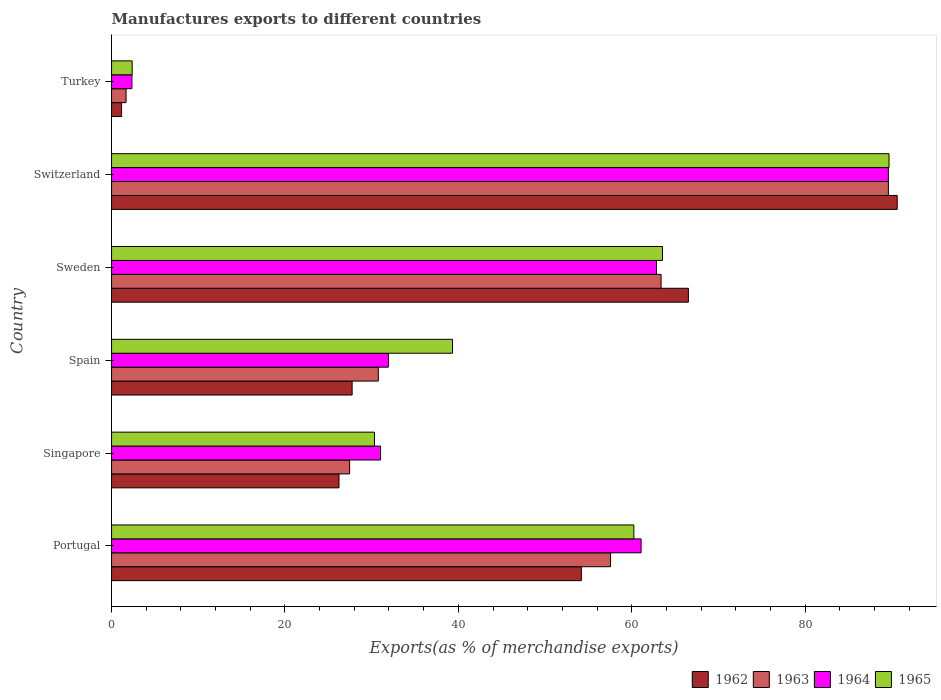Are the number of bars per tick equal to the number of legend labels?
Give a very brief answer. Yes. How many bars are there on the 4th tick from the bottom?
Offer a terse response. 4. What is the label of the 2nd group of bars from the top?
Provide a succinct answer. Switzerland. What is the percentage of exports to different countries in 1964 in Spain?
Offer a very short reply. 31.93. Across all countries, what is the maximum percentage of exports to different countries in 1964?
Keep it short and to the point. 89.61. Across all countries, what is the minimum percentage of exports to different countries in 1963?
Ensure brevity in your answer.  1.67. In which country was the percentage of exports to different countries in 1962 maximum?
Your response must be concise. Switzerland. In which country was the percentage of exports to different countries in 1965 minimum?
Your response must be concise. Turkey. What is the total percentage of exports to different countries in 1964 in the graph?
Your answer should be compact. 278.86. What is the difference between the percentage of exports to different countries in 1964 in Singapore and that in Sweden?
Offer a very short reply. -31.83. What is the difference between the percentage of exports to different countries in 1962 in Sweden and the percentage of exports to different countries in 1963 in Spain?
Your answer should be compact. 35.77. What is the average percentage of exports to different countries in 1962 per country?
Provide a short and direct response. 44.42. What is the difference between the percentage of exports to different countries in 1964 and percentage of exports to different countries in 1962 in Sweden?
Your answer should be compact. -3.68. In how many countries, is the percentage of exports to different countries in 1964 greater than 76 %?
Provide a short and direct response. 1. What is the ratio of the percentage of exports to different countries in 1965 in Sweden to that in Switzerland?
Your answer should be very brief. 0.71. Is the difference between the percentage of exports to different countries in 1964 in Portugal and Sweden greater than the difference between the percentage of exports to different countries in 1962 in Portugal and Sweden?
Make the answer very short. Yes. What is the difference between the highest and the second highest percentage of exports to different countries in 1964?
Your response must be concise. 26.75. What is the difference between the highest and the lowest percentage of exports to different countries in 1963?
Make the answer very short. 87.94. In how many countries, is the percentage of exports to different countries in 1963 greater than the average percentage of exports to different countries in 1963 taken over all countries?
Offer a terse response. 3. What does the 2nd bar from the top in Spain represents?
Your answer should be compact. 1964. What does the 2nd bar from the bottom in Turkey represents?
Provide a succinct answer. 1963. Is it the case that in every country, the sum of the percentage of exports to different countries in 1964 and percentage of exports to different countries in 1965 is greater than the percentage of exports to different countries in 1962?
Make the answer very short. Yes. How many bars are there?
Offer a terse response. 24. Does the graph contain any zero values?
Provide a short and direct response. No. Where does the legend appear in the graph?
Provide a short and direct response. Bottom right. How many legend labels are there?
Your answer should be compact. 4. What is the title of the graph?
Give a very brief answer. Manufactures exports to different countries. Does "1983" appear as one of the legend labels in the graph?
Offer a terse response. No. What is the label or title of the X-axis?
Offer a very short reply. Exports(as % of merchandise exports). What is the label or title of the Y-axis?
Keep it short and to the point. Country. What is the Exports(as % of merchandise exports) in 1962 in Portugal?
Ensure brevity in your answer.  54.19. What is the Exports(as % of merchandise exports) of 1963 in Portugal?
Provide a short and direct response. 57.56. What is the Exports(as % of merchandise exports) of 1964 in Portugal?
Offer a terse response. 61.08. What is the Exports(as % of merchandise exports) in 1965 in Portugal?
Make the answer very short. 60.25. What is the Exports(as % of merchandise exports) of 1962 in Singapore?
Offer a very short reply. 26.24. What is the Exports(as % of merchandise exports) in 1963 in Singapore?
Ensure brevity in your answer.  27.46. What is the Exports(as % of merchandise exports) in 1964 in Singapore?
Give a very brief answer. 31.03. What is the Exports(as % of merchandise exports) of 1965 in Singapore?
Offer a very short reply. 30.33. What is the Exports(as % of merchandise exports) of 1962 in Spain?
Give a very brief answer. 27.75. What is the Exports(as % of merchandise exports) in 1963 in Spain?
Your response must be concise. 30.77. What is the Exports(as % of merchandise exports) in 1964 in Spain?
Make the answer very short. 31.93. What is the Exports(as % of merchandise exports) of 1965 in Spain?
Offer a very short reply. 39.33. What is the Exports(as % of merchandise exports) of 1962 in Sweden?
Make the answer very short. 66.54. What is the Exports(as % of merchandise exports) of 1963 in Sweden?
Keep it short and to the point. 63.39. What is the Exports(as % of merchandise exports) of 1964 in Sweden?
Keep it short and to the point. 62.86. What is the Exports(as % of merchandise exports) in 1965 in Sweden?
Your answer should be very brief. 63.55. What is the Exports(as % of merchandise exports) of 1962 in Switzerland?
Your answer should be very brief. 90.63. What is the Exports(as % of merchandise exports) of 1963 in Switzerland?
Your response must be concise. 89.61. What is the Exports(as % of merchandise exports) in 1964 in Switzerland?
Offer a very short reply. 89.61. What is the Exports(as % of merchandise exports) in 1965 in Switzerland?
Make the answer very short. 89.68. What is the Exports(as % of merchandise exports) in 1962 in Turkey?
Your response must be concise. 1.16. What is the Exports(as % of merchandise exports) in 1963 in Turkey?
Ensure brevity in your answer.  1.67. What is the Exports(as % of merchandise exports) of 1964 in Turkey?
Your response must be concise. 2.35. What is the Exports(as % of merchandise exports) in 1965 in Turkey?
Your answer should be compact. 2.38. Across all countries, what is the maximum Exports(as % of merchandise exports) in 1962?
Offer a terse response. 90.63. Across all countries, what is the maximum Exports(as % of merchandise exports) in 1963?
Make the answer very short. 89.61. Across all countries, what is the maximum Exports(as % of merchandise exports) in 1964?
Ensure brevity in your answer.  89.61. Across all countries, what is the maximum Exports(as % of merchandise exports) of 1965?
Ensure brevity in your answer.  89.68. Across all countries, what is the minimum Exports(as % of merchandise exports) in 1962?
Provide a succinct answer. 1.16. Across all countries, what is the minimum Exports(as % of merchandise exports) in 1963?
Offer a terse response. 1.67. Across all countries, what is the minimum Exports(as % of merchandise exports) in 1964?
Provide a short and direct response. 2.35. Across all countries, what is the minimum Exports(as % of merchandise exports) of 1965?
Give a very brief answer. 2.38. What is the total Exports(as % of merchandise exports) of 1962 in the graph?
Provide a succinct answer. 266.5. What is the total Exports(as % of merchandise exports) in 1963 in the graph?
Offer a terse response. 270.46. What is the total Exports(as % of merchandise exports) in 1964 in the graph?
Keep it short and to the point. 278.86. What is the total Exports(as % of merchandise exports) in 1965 in the graph?
Offer a terse response. 285.53. What is the difference between the Exports(as % of merchandise exports) of 1962 in Portugal and that in Singapore?
Your answer should be very brief. 27.96. What is the difference between the Exports(as % of merchandise exports) in 1963 in Portugal and that in Singapore?
Your response must be concise. 30.1. What is the difference between the Exports(as % of merchandise exports) in 1964 in Portugal and that in Singapore?
Your answer should be compact. 30.05. What is the difference between the Exports(as % of merchandise exports) in 1965 in Portugal and that in Singapore?
Make the answer very short. 29.92. What is the difference between the Exports(as % of merchandise exports) in 1962 in Portugal and that in Spain?
Provide a short and direct response. 26.44. What is the difference between the Exports(as % of merchandise exports) in 1963 in Portugal and that in Spain?
Provide a short and direct response. 26.79. What is the difference between the Exports(as % of merchandise exports) in 1964 in Portugal and that in Spain?
Keep it short and to the point. 29.15. What is the difference between the Exports(as % of merchandise exports) in 1965 in Portugal and that in Spain?
Offer a terse response. 20.92. What is the difference between the Exports(as % of merchandise exports) in 1962 in Portugal and that in Sweden?
Keep it short and to the point. -12.35. What is the difference between the Exports(as % of merchandise exports) of 1963 in Portugal and that in Sweden?
Give a very brief answer. -5.83. What is the difference between the Exports(as % of merchandise exports) in 1964 in Portugal and that in Sweden?
Keep it short and to the point. -1.77. What is the difference between the Exports(as % of merchandise exports) in 1965 in Portugal and that in Sweden?
Make the answer very short. -3.3. What is the difference between the Exports(as % of merchandise exports) in 1962 in Portugal and that in Switzerland?
Provide a succinct answer. -36.44. What is the difference between the Exports(as % of merchandise exports) in 1963 in Portugal and that in Switzerland?
Ensure brevity in your answer.  -32.05. What is the difference between the Exports(as % of merchandise exports) in 1964 in Portugal and that in Switzerland?
Your answer should be very brief. -28.53. What is the difference between the Exports(as % of merchandise exports) in 1965 in Portugal and that in Switzerland?
Provide a short and direct response. -29.43. What is the difference between the Exports(as % of merchandise exports) of 1962 in Portugal and that in Turkey?
Keep it short and to the point. 53.04. What is the difference between the Exports(as % of merchandise exports) of 1963 in Portugal and that in Turkey?
Give a very brief answer. 55.89. What is the difference between the Exports(as % of merchandise exports) in 1964 in Portugal and that in Turkey?
Keep it short and to the point. 58.73. What is the difference between the Exports(as % of merchandise exports) of 1965 in Portugal and that in Turkey?
Keep it short and to the point. 57.87. What is the difference between the Exports(as % of merchandise exports) of 1962 in Singapore and that in Spain?
Your response must be concise. -1.51. What is the difference between the Exports(as % of merchandise exports) in 1963 in Singapore and that in Spain?
Make the answer very short. -3.31. What is the difference between the Exports(as % of merchandise exports) in 1964 in Singapore and that in Spain?
Make the answer very short. -0.9. What is the difference between the Exports(as % of merchandise exports) in 1965 in Singapore and that in Spain?
Make the answer very short. -9. What is the difference between the Exports(as % of merchandise exports) in 1962 in Singapore and that in Sweden?
Give a very brief answer. -40.3. What is the difference between the Exports(as % of merchandise exports) of 1963 in Singapore and that in Sweden?
Your response must be concise. -35.93. What is the difference between the Exports(as % of merchandise exports) of 1964 in Singapore and that in Sweden?
Ensure brevity in your answer.  -31.83. What is the difference between the Exports(as % of merchandise exports) in 1965 in Singapore and that in Sweden?
Keep it short and to the point. -33.22. What is the difference between the Exports(as % of merchandise exports) in 1962 in Singapore and that in Switzerland?
Ensure brevity in your answer.  -64.39. What is the difference between the Exports(as % of merchandise exports) in 1963 in Singapore and that in Switzerland?
Ensure brevity in your answer.  -62.15. What is the difference between the Exports(as % of merchandise exports) in 1964 in Singapore and that in Switzerland?
Provide a succinct answer. -58.58. What is the difference between the Exports(as % of merchandise exports) of 1965 in Singapore and that in Switzerland?
Offer a terse response. -59.35. What is the difference between the Exports(as % of merchandise exports) of 1962 in Singapore and that in Turkey?
Ensure brevity in your answer.  25.08. What is the difference between the Exports(as % of merchandise exports) of 1963 in Singapore and that in Turkey?
Your response must be concise. 25.79. What is the difference between the Exports(as % of merchandise exports) of 1964 in Singapore and that in Turkey?
Offer a very short reply. 28.68. What is the difference between the Exports(as % of merchandise exports) in 1965 in Singapore and that in Turkey?
Offer a terse response. 27.95. What is the difference between the Exports(as % of merchandise exports) of 1962 in Spain and that in Sweden?
Your response must be concise. -38.79. What is the difference between the Exports(as % of merchandise exports) of 1963 in Spain and that in Sweden?
Your answer should be very brief. -32.62. What is the difference between the Exports(as % of merchandise exports) in 1964 in Spain and that in Sweden?
Give a very brief answer. -30.92. What is the difference between the Exports(as % of merchandise exports) in 1965 in Spain and that in Sweden?
Your response must be concise. -24.22. What is the difference between the Exports(as % of merchandise exports) of 1962 in Spain and that in Switzerland?
Provide a short and direct response. -62.88. What is the difference between the Exports(as % of merchandise exports) of 1963 in Spain and that in Switzerland?
Make the answer very short. -58.84. What is the difference between the Exports(as % of merchandise exports) in 1964 in Spain and that in Switzerland?
Give a very brief answer. -57.68. What is the difference between the Exports(as % of merchandise exports) in 1965 in Spain and that in Switzerland?
Your answer should be very brief. -50.35. What is the difference between the Exports(as % of merchandise exports) of 1962 in Spain and that in Turkey?
Give a very brief answer. 26.59. What is the difference between the Exports(as % of merchandise exports) of 1963 in Spain and that in Turkey?
Your answer should be compact. 29.1. What is the difference between the Exports(as % of merchandise exports) of 1964 in Spain and that in Turkey?
Provide a short and direct response. 29.58. What is the difference between the Exports(as % of merchandise exports) in 1965 in Spain and that in Turkey?
Offer a terse response. 36.96. What is the difference between the Exports(as % of merchandise exports) in 1962 in Sweden and that in Switzerland?
Ensure brevity in your answer.  -24.09. What is the difference between the Exports(as % of merchandise exports) in 1963 in Sweden and that in Switzerland?
Your answer should be very brief. -26.22. What is the difference between the Exports(as % of merchandise exports) of 1964 in Sweden and that in Switzerland?
Provide a short and direct response. -26.75. What is the difference between the Exports(as % of merchandise exports) in 1965 in Sweden and that in Switzerland?
Give a very brief answer. -26.13. What is the difference between the Exports(as % of merchandise exports) in 1962 in Sweden and that in Turkey?
Keep it short and to the point. 65.38. What is the difference between the Exports(as % of merchandise exports) in 1963 in Sweden and that in Turkey?
Offer a terse response. 61.72. What is the difference between the Exports(as % of merchandise exports) in 1964 in Sweden and that in Turkey?
Provide a short and direct response. 60.51. What is the difference between the Exports(as % of merchandise exports) in 1965 in Sweden and that in Turkey?
Your answer should be compact. 61.17. What is the difference between the Exports(as % of merchandise exports) of 1962 in Switzerland and that in Turkey?
Provide a succinct answer. 89.47. What is the difference between the Exports(as % of merchandise exports) in 1963 in Switzerland and that in Turkey?
Your answer should be very brief. 87.94. What is the difference between the Exports(as % of merchandise exports) in 1964 in Switzerland and that in Turkey?
Offer a very short reply. 87.26. What is the difference between the Exports(as % of merchandise exports) in 1965 in Switzerland and that in Turkey?
Make the answer very short. 87.31. What is the difference between the Exports(as % of merchandise exports) of 1962 in Portugal and the Exports(as % of merchandise exports) of 1963 in Singapore?
Provide a short and direct response. 26.73. What is the difference between the Exports(as % of merchandise exports) in 1962 in Portugal and the Exports(as % of merchandise exports) in 1964 in Singapore?
Your answer should be compact. 23.16. What is the difference between the Exports(as % of merchandise exports) in 1962 in Portugal and the Exports(as % of merchandise exports) in 1965 in Singapore?
Give a very brief answer. 23.86. What is the difference between the Exports(as % of merchandise exports) in 1963 in Portugal and the Exports(as % of merchandise exports) in 1964 in Singapore?
Provide a short and direct response. 26.53. What is the difference between the Exports(as % of merchandise exports) of 1963 in Portugal and the Exports(as % of merchandise exports) of 1965 in Singapore?
Keep it short and to the point. 27.23. What is the difference between the Exports(as % of merchandise exports) in 1964 in Portugal and the Exports(as % of merchandise exports) in 1965 in Singapore?
Give a very brief answer. 30.75. What is the difference between the Exports(as % of merchandise exports) of 1962 in Portugal and the Exports(as % of merchandise exports) of 1963 in Spain?
Your answer should be compact. 23.42. What is the difference between the Exports(as % of merchandise exports) in 1962 in Portugal and the Exports(as % of merchandise exports) in 1964 in Spain?
Your response must be concise. 22.26. What is the difference between the Exports(as % of merchandise exports) of 1962 in Portugal and the Exports(as % of merchandise exports) of 1965 in Spain?
Make the answer very short. 14.86. What is the difference between the Exports(as % of merchandise exports) of 1963 in Portugal and the Exports(as % of merchandise exports) of 1964 in Spain?
Offer a terse response. 25.63. What is the difference between the Exports(as % of merchandise exports) of 1963 in Portugal and the Exports(as % of merchandise exports) of 1965 in Spain?
Offer a very short reply. 18.23. What is the difference between the Exports(as % of merchandise exports) of 1964 in Portugal and the Exports(as % of merchandise exports) of 1965 in Spain?
Keep it short and to the point. 21.75. What is the difference between the Exports(as % of merchandise exports) of 1962 in Portugal and the Exports(as % of merchandise exports) of 1963 in Sweden?
Your answer should be compact. -9.2. What is the difference between the Exports(as % of merchandise exports) of 1962 in Portugal and the Exports(as % of merchandise exports) of 1964 in Sweden?
Ensure brevity in your answer.  -8.66. What is the difference between the Exports(as % of merchandise exports) in 1962 in Portugal and the Exports(as % of merchandise exports) in 1965 in Sweden?
Give a very brief answer. -9.36. What is the difference between the Exports(as % of merchandise exports) of 1963 in Portugal and the Exports(as % of merchandise exports) of 1964 in Sweden?
Provide a succinct answer. -5.3. What is the difference between the Exports(as % of merchandise exports) of 1963 in Portugal and the Exports(as % of merchandise exports) of 1965 in Sweden?
Your answer should be compact. -5.99. What is the difference between the Exports(as % of merchandise exports) of 1964 in Portugal and the Exports(as % of merchandise exports) of 1965 in Sweden?
Provide a succinct answer. -2.47. What is the difference between the Exports(as % of merchandise exports) in 1962 in Portugal and the Exports(as % of merchandise exports) in 1963 in Switzerland?
Offer a terse response. -35.42. What is the difference between the Exports(as % of merchandise exports) in 1962 in Portugal and the Exports(as % of merchandise exports) in 1964 in Switzerland?
Give a very brief answer. -35.42. What is the difference between the Exports(as % of merchandise exports) of 1962 in Portugal and the Exports(as % of merchandise exports) of 1965 in Switzerland?
Offer a very short reply. -35.49. What is the difference between the Exports(as % of merchandise exports) of 1963 in Portugal and the Exports(as % of merchandise exports) of 1964 in Switzerland?
Provide a succinct answer. -32.05. What is the difference between the Exports(as % of merchandise exports) in 1963 in Portugal and the Exports(as % of merchandise exports) in 1965 in Switzerland?
Your answer should be very brief. -32.12. What is the difference between the Exports(as % of merchandise exports) of 1964 in Portugal and the Exports(as % of merchandise exports) of 1965 in Switzerland?
Your response must be concise. -28.6. What is the difference between the Exports(as % of merchandise exports) of 1962 in Portugal and the Exports(as % of merchandise exports) of 1963 in Turkey?
Provide a short and direct response. 52.52. What is the difference between the Exports(as % of merchandise exports) in 1962 in Portugal and the Exports(as % of merchandise exports) in 1964 in Turkey?
Make the answer very short. 51.84. What is the difference between the Exports(as % of merchandise exports) of 1962 in Portugal and the Exports(as % of merchandise exports) of 1965 in Turkey?
Make the answer very short. 51.81. What is the difference between the Exports(as % of merchandise exports) of 1963 in Portugal and the Exports(as % of merchandise exports) of 1964 in Turkey?
Give a very brief answer. 55.21. What is the difference between the Exports(as % of merchandise exports) in 1963 in Portugal and the Exports(as % of merchandise exports) in 1965 in Turkey?
Offer a terse response. 55.18. What is the difference between the Exports(as % of merchandise exports) in 1964 in Portugal and the Exports(as % of merchandise exports) in 1965 in Turkey?
Make the answer very short. 58.7. What is the difference between the Exports(as % of merchandise exports) of 1962 in Singapore and the Exports(as % of merchandise exports) of 1963 in Spain?
Your response must be concise. -4.53. What is the difference between the Exports(as % of merchandise exports) of 1962 in Singapore and the Exports(as % of merchandise exports) of 1964 in Spain?
Your answer should be very brief. -5.7. What is the difference between the Exports(as % of merchandise exports) in 1962 in Singapore and the Exports(as % of merchandise exports) in 1965 in Spain?
Your response must be concise. -13.1. What is the difference between the Exports(as % of merchandise exports) of 1963 in Singapore and the Exports(as % of merchandise exports) of 1964 in Spain?
Your answer should be compact. -4.47. What is the difference between the Exports(as % of merchandise exports) of 1963 in Singapore and the Exports(as % of merchandise exports) of 1965 in Spain?
Make the answer very short. -11.87. What is the difference between the Exports(as % of merchandise exports) in 1964 in Singapore and the Exports(as % of merchandise exports) in 1965 in Spain?
Offer a terse response. -8.3. What is the difference between the Exports(as % of merchandise exports) in 1962 in Singapore and the Exports(as % of merchandise exports) in 1963 in Sweden?
Ensure brevity in your answer.  -37.15. What is the difference between the Exports(as % of merchandise exports) of 1962 in Singapore and the Exports(as % of merchandise exports) of 1964 in Sweden?
Your answer should be compact. -36.62. What is the difference between the Exports(as % of merchandise exports) of 1962 in Singapore and the Exports(as % of merchandise exports) of 1965 in Sweden?
Give a very brief answer. -37.31. What is the difference between the Exports(as % of merchandise exports) in 1963 in Singapore and the Exports(as % of merchandise exports) in 1964 in Sweden?
Your answer should be very brief. -35.4. What is the difference between the Exports(as % of merchandise exports) of 1963 in Singapore and the Exports(as % of merchandise exports) of 1965 in Sweden?
Provide a succinct answer. -36.09. What is the difference between the Exports(as % of merchandise exports) in 1964 in Singapore and the Exports(as % of merchandise exports) in 1965 in Sweden?
Give a very brief answer. -32.52. What is the difference between the Exports(as % of merchandise exports) in 1962 in Singapore and the Exports(as % of merchandise exports) in 1963 in Switzerland?
Your response must be concise. -63.37. What is the difference between the Exports(as % of merchandise exports) in 1962 in Singapore and the Exports(as % of merchandise exports) in 1964 in Switzerland?
Make the answer very short. -63.37. What is the difference between the Exports(as % of merchandise exports) of 1962 in Singapore and the Exports(as % of merchandise exports) of 1965 in Switzerland?
Give a very brief answer. -63.45. What is the difference between the Exports(as % of merchandise exports) in 1963 in Singapore and the Exports(as % of merchandise exports) in 1964 in Switzerland?
Offer a very short reply. -62.15. What is the difference between the Exports(as % of merchandise exports) of 1963 in Singapore and the Exports(as % of merchandise exports) of 1965 in Switzerland?
Offer a very short reply. -62.22. What is the difference between the Exports(as % of merchandise exports) of 1964 in Singapore and the Exports(as % of merchandise exports) of 1965 in Switzerland?
Provide a succinct answer. -58.65. What is the difference between the Exports(as % of merchandise exports) of 1962 in Singapore and the Exports(as % of merchandise exports) of 1963 in Turkey?
Your answer should be compact. 24.56. What is the difference between the Exports(as % of merchandise exports) in 1962 in Singapore and the Exports(as % of merchandise exports) in 1964 in Turkey?
Give a very brief answer. 23.89. What is the difference between the Exports(as % of merchandise exports) of 1962 in Singapore and the Exports(as % of merchandise exports) of 1965 in Turkey?
Your answer should be very brief. 23.86. What is the difference between the Exports(as % of merchandise exports) of 1963 in Singapore and the Exports(as % of merchandise exports) of 1964 in Turkey?
Make the answer very short. 25.11. What is the difference between the Exports(as % of merchandise exports) of 1963 in Singapore and the Exports(as % of merchandise exports) of 1965 in Turkey?
Your response must be concise. 25.08. What is the difference between the Exports(as % of merchandise exports) of 1964 in Singapore and the Exports(as % of merchandise exports) of 1965 in Turkey?
Provide a short and direct response. 28.65. What is the difference between the Exports(as % of merchandise exports) in 1962 in Spain and the Exports(as % of merchandise exports) in 1963 in Sweden?
Offer a terse response. -35.64. What is the difference between the Exports(as % of merchandise exports) in 1962 in Spain and the Exports(as % of merchandise exports) in 1964 in Sweden?
Your response must be concise. -35.11. What is the difference between the Exports(as % of merchandise exports) of 1962 in Spain and the Exports(as % of merchandise exports) of 1965 in Sweden?
Offer a very short reply. -35.8. What is the difference between the Exports(as % of merchandise exports) of 1963 in Spain and the Exports(as % of merchandise exports) of 1964 in Sweden?
Your answer should be very brief. -32.09. What is the difference between the Exports(as % of merchandise exports) of 1963 in Spain and the Exports(as % of merchandise exports) of 1965 in Sweden?
Offer a terse response. -32.78. What is the difference between the Exports(as % of merchandise exports) in 1964 in Spain and the Exports(as % of merchandise exports) in 1965 in Sweden?
Keep it short and to the point. -31.62. What is the difference between the Exports(as % of merchandise exports) of 1962 in Spain and the Exports(as % of merchandise exports) of 1963 in Switzerland?
Make the answer very short. -61.86. What is the difference between the Exports(as % of merchandise exports) of 1962 in Spain and the Exports(as % of merchandise exports) of 1964 in Switzerland?
Your answer should be compact. -61.86. What is the difference between the Exports(as % of merchandise exports) in 1962 in Spain and the Exports(as % of merchandise exports) in 1965 in Switzerland?
Give a very brief answer. -61.93. What is the difference between the Exports(as % of merchandise exports) in 1963 in Spain and the Exports(as % of merchandise exports) in 1964 in Switzerland?
Offer a very short reply. -58.84. What is the difference between the Exports(as % of merchandise exports) of 1963 in Spain and the Exports(as % of merchandise exports) of 1965 in Switzerland?
Give a very brief answer. -58.91. What is the difference between the Exports(as % of merchandise exports) of 1964 in Spain and the Exports(as % of merchandise exports) of 1965 in Switzerland?
Provide a short and direct response. -57.75. What is the difference between the Exports(as % of merchandise exports) in 1962 in Spain and the Exports(as % of merchandise exports) in 1963 in Turkey?
Offer a terse response. 26.08. What is the difference between the Exports(as % of merchandise exports) in 1962 in Spain and the Exports(as % of merchandise exports) in 1964 in Turkey?
Offer a terse response. 25.4. What is the difference between the Exports(as % of merchandise exports) in 1962 in Spain and the Exports(as % of merchandise exports) in 1965 in Turkey?
Your answer should be compact. 25.37. What is the difference between the Exports(as % of merchandise exports) of 1963 in Spain and the Exports(as % of merchandise exports) of 1964 in Turkey?
Keep it short and to the point. 28.42. What is the difference between the Exports(as % of merchandise exports) in 1963 in Spain and the Exports(as % of merchandise exports) in 1965 in Turkey?
Your answer should be compact. 28.39. What is the difference between the Exports(as % of merchandise exports) of 1964 in Spain and the Exports(as % of merchandise exports) of 1965 in Turkey?
Offer a terse response. 29.56. What is the difference between the Exports(as % of merchandise exports) in 1962 in Sweden and the Exports(as % of merchandise exports) in 1963 in Switzerland?
Give a very brief answer. -23.07. What is the difference between the Exports(as % of merchandise exports) in 1962 in Sweden and the Exports(as % of merchandise exports) in 1964 in Switzerland?
Keep it short and to the point. -23.07. What is the difference between the Exports(as % of merchandise exports) of 1962 in Sweden and the Exports(as % of merchandise exports) of 1965 in Switzerland?
Ensure brevity in your answer.  -23.15. What is the difference between the Exports(as % of merchandise exports) in 1963 in Sweden and the Exports(as % of merchandise exports) in 1964 in Switzerland?
Ensure brevity in your answer.  -26.22. What is the difference between the Exports(as % of merchandise exports) in 1963 in Sweden and the Exports(as % of merchandise exports) in 1965 in Switzerland?
Give a very brief answer. -26.3. What is the difference between the Exports(as % of merchandise exports) in 1964 in Sweden and the Exports(as % of merchandise exports) in 1965 in Switzerland?
Ensure brevity in your answer.  -26.83. What is the difference between the Exports(as % of merchandise exports) of 1962 in Sweden and the Exports(as % of merchandise exports) of 1963 in Turkey?
Your response must be concise. 64.86. What is the difference between the Exports(as % of merchandise exports) of 1962 in Sweden and the Exports(as % of merchandise exports) of 1964 in Turkey?
Your answer should be compact. 64.19. What is the difference between the Exports(as % of merchandise exports) in 1962 in Sweden and the Exports(as % of merchandise exports) in 1965 in Turkey?
Offer a very short reply. 64.16. What is the difference between the Exports(as % of merchandise exports) in 1963 in Sweden and the Exports(as % of merchandise exports) in 1964 in Turkey?
Make the answer very short. 61.04. What is the difference between the Exports(as % of merchandise exports) of 1963 in Sweden and the Exports(as % of merchandise exports) of 1965 in Turkey?
Your response must be concise. 61.01. What is the difference between the Exports(as % of merchandise exports) in 1964 in Sweden and the Exports(as % of merchandise exports) in 1965 in Turkey?
Your response must be concise. 60.48. What is the difference between the Exports(as % of merchandise exports) in 1962 in Switzerland and the Exports(as % of merchandise exports) in 1963 in Turkey?
Ensure brevity in your answer.  88.95. What is the difference between the Exports(as % of merchandise exports) in 1962 in Switzerland and the Exports(as % of merchandise exports) in 1964 in Turkey?
Provide a short and direct response. 88.28. What is the difference between the Exports(as % of merchandise exports) of 1962 in Switzerland and the Exports(as % of merchandise exports) of 1965 in Turkey?
Your response must be concise. 88.25. What is the difference between the Exports(as % of merchandise exports) in 1963 in Switzerland and the Exports(as % of merchandise exports) in 1964 in Turkey?
Offer a very short reply. 87.26. What is the difference between the Exports(as % of merchandise exports) in 1963 in Switzerland and the Exports(as % of merchandise exports) in 1965 in Turkey?
Provide a short and direct response. 87.23. What is the difference between the Exports(as % of merchandise exports) of 1964 in Switzerland and the Exports(as % of merchandise exports) of 1965 in Turkey?
Offer a terse response. 87.23. What is the average Exports(as % of merchandise exports) in 1962 per country?
Provide a short and direct response. 44.42. What is the average Exports(as % of merchandise exports) of 1963 per country?
Give a very brief answer. 45.08. What is the average Exports(as % of merchandise exports) in 1964 per country?
Your answer should be very brief. 46.48. What is the average Exports(as % of merchandise exports) of 1965 per country?
Offer a terse response. 47.59. What is the difference between the Exports(as % of merchandise exports) of 1962 and Exports(as % of merchandise exports) of 1963 in Portugal?
Make the answer very short. -3.37. What is the difference between the Exports(as % of merchandise exports) of 1962 and Exports(as % of merchandise exports) of 1964 in Portugal?
Your answer should be very brief. -6.89. What is the difference between the Exports(as % of merchandise exports) of 1962 and Exports(as % of merchandise exports) of 1965 in Portugal?
Your answer should be very brief. -6.06. What is the difference between the Exports(as % of merchandise exports) of 1963 and Exports(as % of merchandise exports) of 1964 in Portugal?
Give a very brief answer. -3.52. What is the difference between the Exports(as % of merchandise exports) of 1963 and Exports(as % of merchandise exports) of 1965 in Portugal?
Offer a terse response. -2.69. What is the difference between the Exports(as % of merchandise exports) of 1964 and Exports(as % of merchandise exports) of 1965 in Portugal?
Ensure brevity in your answer.  0.83. What is the difference between the Exports(as % of merchandise exports) of 1962 and Exports(as % of merchandise exports) of 1963 in Singapore?
Give a very brief answer. -1.22. What is the difference between the Exports(as % of merchandise exports) in 1962 and Exports(as % of merchandise exports) in 1964 in Singapore?
Provide a short and direct response. -4.79. What is the difference between the Exports(as % of merchandise exports) in 1962 and Exports(as % of merchandise exports) in 1965 in Singapore?
Ensure brevity in your answer.  -4.1. What is the difference between the Exports(as % of merchandise exports) in 1963 and Exports(as % of merchandise exports) in 1964 in Singapore?
Your response must be concise. -3.57. What is the difference between the Exports(as % of merchandise exports) of 1963 and Exports(as % of merchandise exports) of 1965 in Singapore?
Ensure brevity in your answer.  -2.87. What is the difference between the Exports(as % of merchandise exports) in 1964 and Exports(as % of merchandise exports) in 1965 in Singapore?
Provide a succinct answer. 0.7. What is the difference between the Exports(as % of merchandise exports) in 1962 and Exports(as % of merchandise exports) in 1963 in Spain?
Offer a very short reply. -3.02. What is the difference between the Exports(as % of merchandise exports) of 1962 and Exports(as % of merchandise exports) of 1964 in Spain?
Provide a short and direct response. -4.18. What is the difference between the Exports(as % of merchandise exports) in 1962 and Exports(as % of merchandise exports) in 1965 in Spain?
Your answer should be compact. -11.58. What is the difference between the Exports(as % of merchandise exports) in 1963 and Exports(as % of merchandise exports) in 1964 in Spain?
Your response must be concise. -1.16. What is the difference between the Exports(as % of merchandise exports) in 1963 and Exports(as % of merchandise exports) in 1965 in Spain?
Provide a short and direct response. -8.56. What is the difference between the Exports(as % of merchandise exports) in 1964 and Exports(as % of merchandise exports) in 1965 in Spain?
Offer a terse response. -7.4. What is the difference between the Exports(as % of merchandise exports) of 1962 and Exports(as % of merchandise exports) of 1963 in Sweden?
Give a very brief answer. 3.15. What is the difference between the Exports(as % of merchandise exports) in 1962 and Exports(as % of merchandise exports) in 1964 in Sweden?
Provide a short and direct response. 3.68. What is the difference between the Exports(as % of merchandise exports) in 1962 and Exports(as % of merchandise exports) in 1965 in Sweden?
Ensure brevity in your answer.  2.99. What is the difference between the Exports(as % of merchandise exports) of 1963 and Exports(as % of merchandise exports) of 1964 in Sweden?
Your answer should be very brief. 0.53. What is the difference between the Exports(as % of merchandise exports) in 1963 and Exports(as % of merchandise exports) in 1965 in Sweden?
Make the answer very short. -0.16. What is the difference between the Exports(as % of merchandise exports) of 1964 and Exports(as % of merchandise exports) of 1965 in Sweden?
Offer a very short reply. -0.69. What is the difference between the Exports(as % of merchandise exports) in 1962 and Exports(as % of merchandise exports) in 1963 in Switzerland?
Give a very brief answer. 1.02. What is the difference between the Exports(as % of merchandise exports) in 1962 and Exports(as % of merchandise exports) in 1964 in Switzerland?
Make the answer very short. 1.02. What is the difference between the Exports(as % of merchandise exports) in 1962 and Exports(as % of merchandise exports) in 1965 in Switzerland?
Your answer should be compact. 0.94. What is the difference between the Exports(as % of merchandise exports) in 1963 and Exports(as % of merchandise exports) in 1964 in Switzerland?
Your answer should be compact. -0. What is the difference between the Exports(as % of merchandise exports) in 1963 and Exports(as % of merchandise exports) in 1965 in Switzerland?
Ensure brevity in your answer.  -0.07. What is the difference between the Exports(as % of merchandise exports) in 1964 and Exports(as % of merchandise exports) in 1965 in Switzerland?
Make the answer very short. -0.07. What is the difference between the Exports(as % of merchandise exports) of 1962 and Exports(as % of merchandise exports) of 1963 in Turkey?
Ensure brevity in your answer.  -0.52. What is the difference between the Exports(as % of merchandise exports) of 1962 and Exports(as % of merchandise exports) of 1964 in Turkey?
Offer a terse response. -1.19. What is the difference between the Exports(as % of merchandise exports) in 1962 and Exports(as % of merchandise exports) in 1965 in Turkey?
Offer a terse response. -1.22. What is the difference between the Exports(as % of merchandise exports) in 1963 and Exports(as % of merchandise exports) in 1964 in Turkey?
Make the answer very short. -0.68. What is the difference between the Exports(as % of merchandise exports) of 1963 and Exports(as % of merchandise exports) of 1965 in Turkey?
Offer a very short reply. -0.7. What is the difference between the Exports(as % of merchandise exports) in 1964 and Exports(as % of merchandise exports) in 1965 in Turkey?
Your response must be concise. -0.03. What is the ratio of the Exports(as % of merchandise exports) of 1962 in Portugal to that in Singapore?
Provide a short and direct response. 2.07. What is the ratio of the Exports(as % of merchandise exports) of 1963 in Portugal to that in Singapore?
Your answer should be very brief. 2.1. What is the ratio of the Exports(as % of merchandise exports) in 1964 in Portugal to that in Singapore?
Your answer should be compact. 1.97. What is the ratio of the Exports(as % of merchandise exports) in 1965 in Portugal to that in Singapore?
Your response must be concise. 1.99. What is the ratio of the Exports(as % of merchandise exports) in 1962 in Portugal to that in Spain?
Provide a short and direct response. 1.95. What is the ratio of the Exports(as % of merchandise exports) in 1963 in Portugal to that in Spain?
Your answer should be very brief. 1.87. What is the ratio of the Exports(as % of merchandise exports) of 1964 in Portugal to that in Spain?
Provide a succinct answer. 1.91. What is the ratio of the Exports(as % of merchandise exports) of 1965 in Portugal to that in Spain?
Give a very brief answer. 1.53. What is the ratio of the Exports(as % of merchandise exports) in 1962 in Portugal to that in Sweden?
Offer a terse response. 0.81. What is the ratio of the Exports(as % of merchandise exports) of 1963 in Portugal to that in Sweden?
Your answer should be compact. 0.91. What is the ratio of the Exports(as % of merchandise exports) in 1964 in Portugal to that in Sweden?
Your response must be concise. 0.97. What is the ratio of the Exports(as % of merchandise exports) in 1965 in Portugal to that in Sweden?
Give a very brief answer. 0.95. What is the ratio of the Exports(as % of merchandise exports) in 1962 in Portugal to that in Switzerland?
Ensure brevity in your answer.  0.6. What is the ratio of the Exports(as % of merchandise exports) in 1963 in Portugal to that in Switzerland?
Keep it short and to the point. 0.64. What is the ratio of the Exports(as % of merchandise exports) of 1964 in Portugal to that in Switzerland?
Your response must be concise. 0.68. What is the ratio of the Exports(as % of merchandise exports) in 1965 in Portugal to that in Switzerland?
Keep it short and to the point. 0.67. What is the ratio of the Exports(as % of merchandise exports) in 1962 in Portugal to that in Turkey?
Make the answer very short. 46.86. What is the ratio of the Exports(as % of merchandise exports) of 1963 in Portugal to that in Turkey?
Your answer should be compact. 34.39. What is the ratio of the Exports(as % of merchandise exports) of 1964 in Portugal to that in Turkey?
Your response must be concise. 25.99. What is the ratio of the Exports(as % of merchandise exports) in 1965 in Portugal to that in Turkey?
Your answer should be compact. 25.34. What is the ratio of the Exports(as % of merchandise exports) of 1962 in Singapore to that in Spain?
Provide a short and direct response. 0.95. What is the ratio of the Exports(as % of merchandise exports) in 1963 in Singapore to that in Spain?
Provide a succinct answer. 0.89. What is the ratio of the Exports(as % of merchandise exports) in 1964 in Singapore to that in Spain?
Offer a terse response. 0.97. What is the ratio of the Exports(as % of merchandise exports) of 1965 in Singapore to that in Spain?
Provide a short and direct response. 0.77. What is the ratio of the Exports(as % of merchandise exports) in 1962 in Singapore to that in Sweden?
Provide a succinct answer. 0.39. What is the ratio of the Exports(as % of merchandise exports) of 1963 in Singapore to that in Sweden?
Your answer should be compact. 0.43. What is the ratio of the Exports(as % of merchandise exports) in 1964 in Singapore to that in Sweden?
Your answer should be very brief. 0.49. What is the ratio of the Exports(as % of merchandise exports) in 1965 in Singapore to that in Sweden?
Ensure brevity in your answer.  0.48. What is the ratio of the Exports(as % of merchandise exports) in 1962 in Singapore to that in Switzerland?
Provide a short and direct response. 0.29. What is the ratio of the Exports(as % of merchandise exports) of 1963 in Singapore to that in Switzerland?
Keep it short and to the point. 0.31. What is the ratio of the Exports(as % of merchandise exports) of 1964 in Singapore to that in Switzerland?
Offer a terse response. 0.35. What is the ratio of the Exports(as % of merchandise exports) of 1965 in Singapore to that in Switzerland?
Your answer should be compact. 0.34. What is the ratio of the Exports(as % of merchandise exports) of 1962 in Singapore to that in Turkey?
Keep it short and to the point. 22.69. What is the ratio of the Exports(as % of merchandise exports) in 1963 in Singapore to that in Turkey?
Your response must be concise. 16.41. What is the ratio of the Exports(as % of merchandise exports) in 1964 in Singapore to that in Turkey?
Give a very brief answer. 13.21. What is the ratio of the Exports(as % of merchandise exports) in 1965 in Singapore to that in Turkey?
Make the answer very short. 12.76. What is the ratio of the Exports(as % of merchandise exports) in 1962 in Spain to that in Sweden?
Keep it short and to the point. 0.42. What is the ratio of the Exports(as % of merchandise exports) in 1963 in Spain to that in Sweden?
Make the answer very short. 0.49. What is the ratio of the Exports(as % of merchandise exports) in 1964 in Spain to that in Sweden?
Give a very brief answer. 0.51. What is the ratio of the Exports(as % of merchandise exports) of 1965 in Spain to that in Sweden?
Give a very brief answer. 0.62. What is the ratio of the Exports(as % of merchandise exports) in 1962 in Spain to that in Switzerland?
Your answer should be very brief. 0.31. What is the ratio of the Exports(as % of merchandise exports) of 1963 in Spain to that in Switzerland?
Keep it short and to the point. 0.34. What is the ratio of the Exports(as % of merchandise exports) of 1964 in Spain to that in Switzerland?
Make the answer very short. 0.36. What is the ratio of the Exports(as % of merchandise exports) in 1965 in Spain to that in Switzerland?
Provide a short and direct response. 0.44. What is the ratio of the Exports(as % of merchandise exports) of 1962 in Spain to that in Turkey?
Keep it short and to the point. 24. What is the ratio of the Exports(as % of merchandise exports) of 1963 in Spain to that in Turkey?
Your response must be concise. 18.38. What is the ratio of the Exports(as % of merchandise exports) in 1964 in Spain to that in Turkey?
Your answer should be very brief. 13.59. What is the ratio of the Exports(as % of merchandise exports) of 1965 in Spain to that in Turkey?
Provide a short and direct response. 16.54. What is the ratio of the Exports(as % of merchandise exports) of 1962 in Sweden to that in Switzerland?
Provide a short and direct response. 0.73. What is the ratio of the Exports(as % of merchandise exports) in 1963 in Sweden to that in Switzerland?
Ensure brevity in your answer.  0.71. What is the ratio of the Exports(as % of merchandise exports) of 1964 in Sweden to that in Switzerland?
Your response must be concise. 0.7. What is the ratio of the Exports(as % of merchandise exports) in 1965 in Sweden to that in Switzerland?
Make the answer very short. 0.71. What is the ratio of the Exports(as % of merchandise exports) in 1962 in Sweden to that in Turkey?
Ensure brevity in your answer.  57.54. What is the ratio of the Exports(as % of merchandise exports) of 1963 in Sweden to that in Turkey?
Provide a succinct answer. 37.87. What is the ratio of the Exports(as % of merchandise exports) in 1964 in Sweden to that in Turkey?
Give a very brief answer. 26.75. What is the ratio of the Exports(as % of merchandise exports) in 1965 in Sweden to that in Turkey?
Provide a short and direct response. 26.73. What is the ratio of the Exports(as % of merchandise exports) in 1962 in Switzerland to that in Turkey?
Provide a short and direct response. 78.37. What is the ratio of the Exports(as % of merchandise exports) in 1963 in Switzerland to that in Turkey?
Keep it short and to the point. 53.54. What is the ratio of the Exports(as % of merchandise exports) of 1964 in Switzerland to that in Turkey?
Offer a terse response. 38.13. What is the ratio of the Exports(as % of merchandise exports) of 1965 in Switzerland to that in Turkey?
Your answer should be very brief. 37.72. What is the difference between the highest and the second highest Exports(as % of merchandise exports) of 1962?
Ensure brevity in your answer.  24.09. What is the difference between the highest and the second highest Exports(as % of merchandise exports) in 1963?
Make the answer very short. 26.22. What is the difference between the highest and the second highest Exports(as % of merchandise exports) of 1964?
Offer a terse response. 26.75. What is the difference between the highest and the second highest Exports(as % of merchandise exports) of 1965?
Provide a succinct answer. 26.13. What is the difference between the highest and the lowest Exports(as % of merchandise exports) of 1962?
Keep it short and to the point. 89.47. What is the difference between the highest and the lowest Exports(as % of merchandise exports) in 1963?
Provide a succinct answer. 87.94. What is the difference between the highest and the lowest Exports(as % of merchandise exports) of 1964?
Offer a very short reply. 87.26. What is the difference between the highest and the lowest Exports(as % of merchandise exports) of 1965?
Make the answer very short. 87.31. 